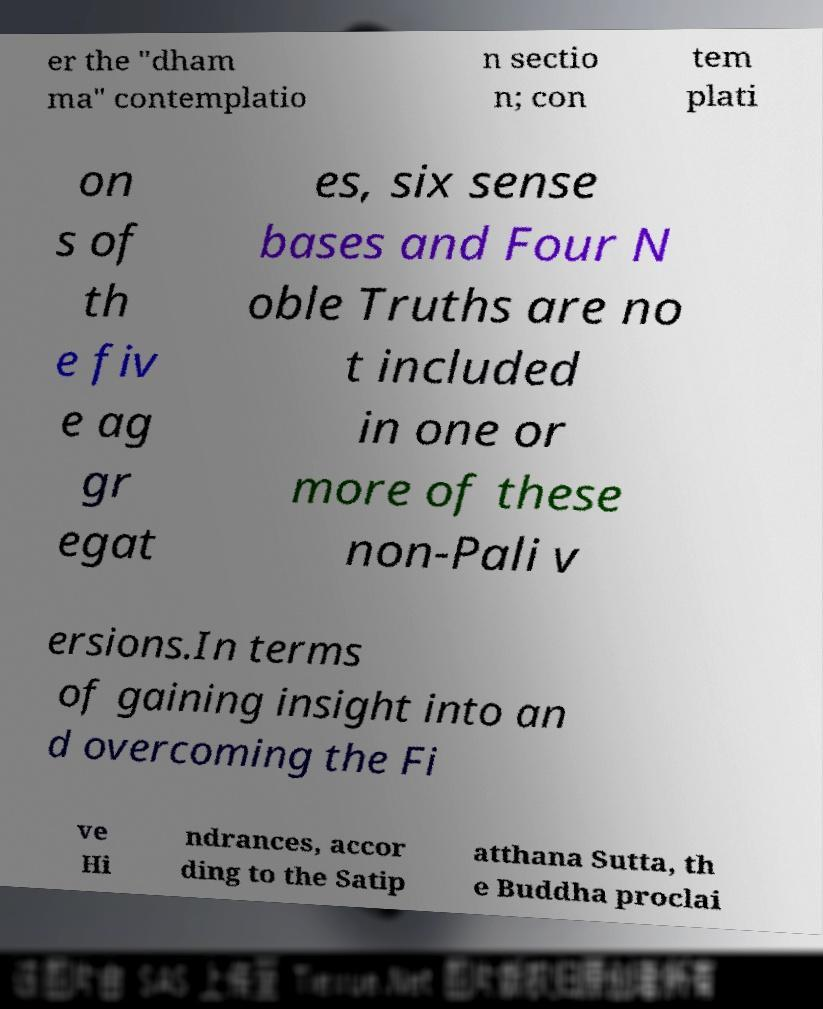I need the written content from this picture converted into text. Can you do that? er the "dham ma" contemplatio n sectio n; con tem plati on s of th e fiv e ag gr egat es, six sense bases and Four N oble Truths are no t included in one or more of these non-Pali v ersions.In terms of gaining insight into an d overcoming the Fi ve Hi ndrances, accor ding to the Satip atthana Sutta, th e Buddha proclai 